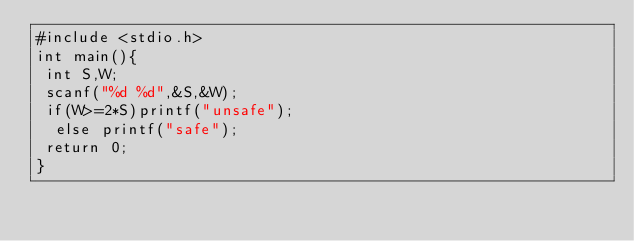<code> <loc_0><loc_0><loc_500><loc_500><_C_>#include <stdio.h>
int main(){
 int S,W;
 scanf("%d %d",&S,&W);
 if(W>=2*S)printf("unsafe");
  else printf("safe");
 return 0;
}</code> 